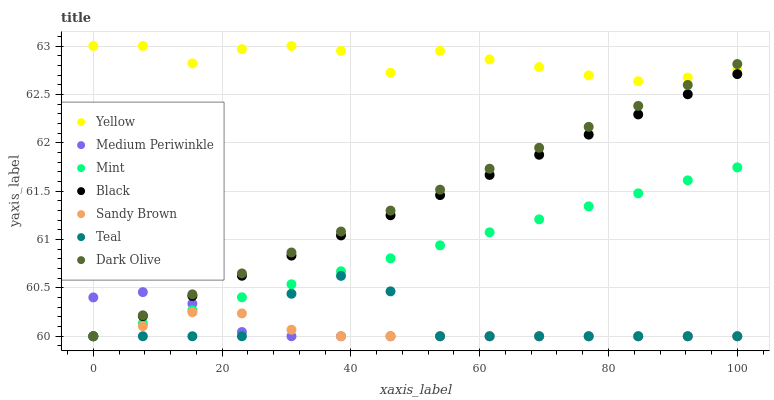Does Sandy Brown have the minimum area under the curve?
Answer yes or no. Yes. Does Yellow have the maximum area under the curve?
Answer yes or no. Yes. Does Dark Olive have the minimum area under the curve?
Answer yes or no. No. Does Dark Olive have the maximum area under the curve?
Answer yes or no. No. Is Mint the smoothest?
Answer yes or no. Yes. Is Yellow the roughest?
Answer yes or no. Yes. Is Dark Olive the smoothest?
Answer yes or no. No. Is Dark Olive the roughest?
Answer yes or no. No. Does Sandy Brown have the lowest value?
Answer yes or no. Yes. Does Yellow have the lowest value?
Answer yes or no. No. Does Yellow have the highest value?
Answer yes or no. Yes. Does Dark Olive have the highest value?
Answer yes or no. No. Is Medium Periwinkle less than Yellow?
Answer yes or no. Yes. Is Yellow greater than Medium Periwinkle?
Answer yes or no. Yes. Does Mint intersect Black?
Answer yes or no. Yes. Is Mint less than Black?
Answer yes or no. No. Is Mint greater than Black?
Answer yes or no. No. Does Medium Periwinkle intersect Yellow?
Answer yes or no. No. 